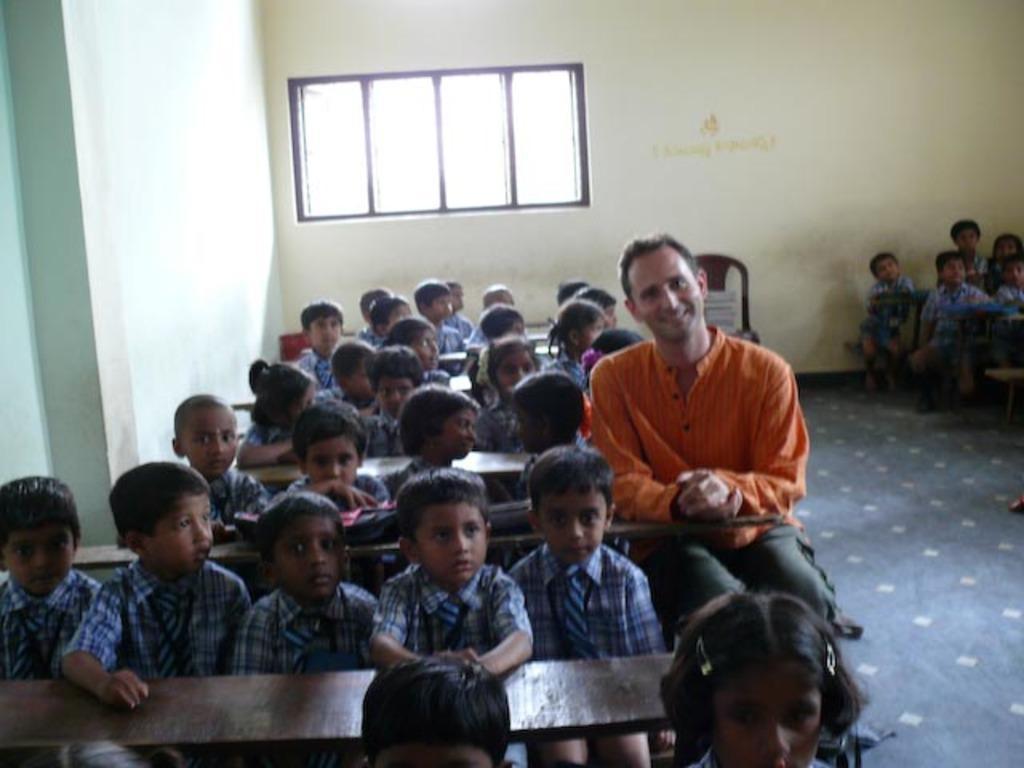How would you summarize this image in a sentence or two? In this picture I can see there are few kids sitting in the bench and there is a man sitting and there are few others sitting at right side and in the backdrop there is a window. 